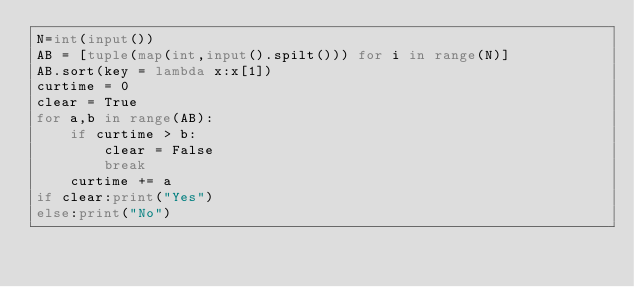<code> <loc_0><loc_0><loc_500><loc_500><_Python_>N=int(input())
AB = [tuple(map(int,input().spilt())) for i in range(N)]
AB.sort(key = lambda x:x[1])
curtime = 0
clear = True
for a,b in range(AB):
    if curtime > b:
        clear = False
        break
    curtime += a
if clear:print("Yes")
else:print("No")</code> 